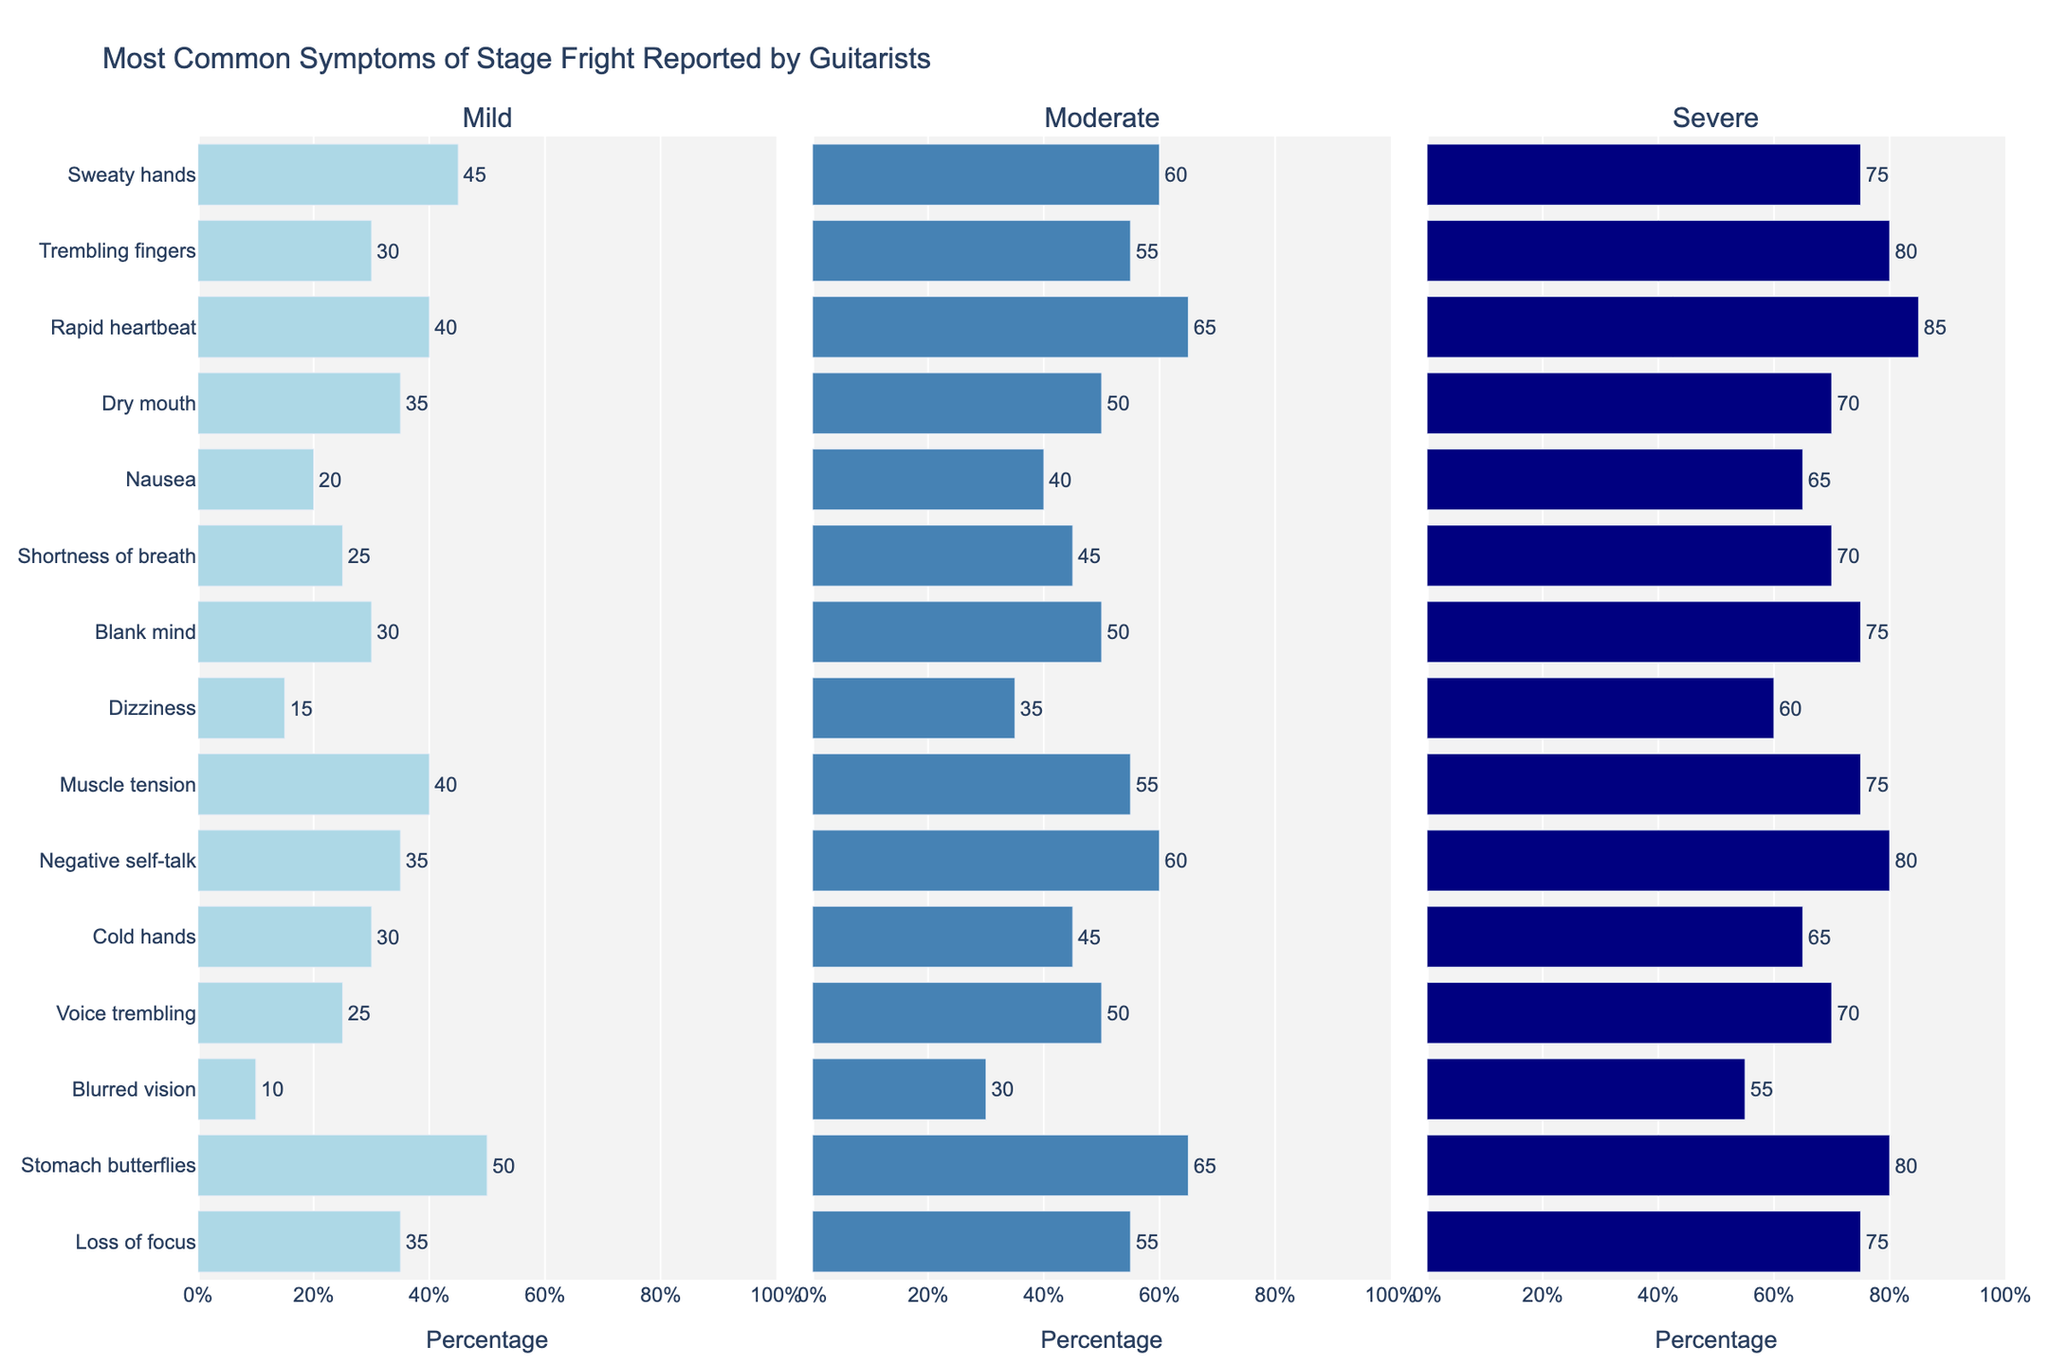Which symptom has the highest percentage reported for severe stage fright? Look at the "Severe" category and identify the bar with the longest length. Rapid Heartbeat has the highest percentage for sever stage fright.
Answer: Rapid Heartbeat Which symptom shows the largest difference in percentage between mild and severe categories? Calculate the difference between percentages for severe and mild categories for each symptom and identify the largest one. Rapid Heartbeat has a difference of 85 - 40 = 45 percentage points.
Answer: Rapid Heartbeat Between Mild and Moderate categories, which symptom has the biggest increase in percentage? Calculate the difference between the percentages in the "Moderate" and "Mild" columns for each symptom. Rapid Heartbeat shows the biggest increase with an increase of 65 - 40 = 25 percentage points.
Answer: Rapid Heartbeat What is the average percentage of guitarists reporting Dizziness for all severity levels? Sum the percentages of guitarists reporting Dizziness for mild (15), moderate (35), and severe (60) levels and then divide by 3. The average is (15 + 35 + 60) / 3 = 110 / 3 ≈ 36.67%.
Answer: 36.67% For which severity level is Stomach butterflies more commonly reported than Negative self-talk? Compare the percentages for Stomach butterflies and Negative self-talk in the Mild, Moderate, and Severe categories. Stomach butterflies are more commonly reported than Negative self-talk in the Mild category (50 vs. 35).
Answer: Mild Which symptom consistently appears in the top three most reported for all severity levels? By comparing all three severity categories, observe symptoms that have some of the highest percentages. Rapid Heartbeat and Stomach butterflies show high percentages across mild, moderate, and severe levels.
Answer: Rapid Heartbeat and Stomach Butterflies If you sum up the mild percentages for Sweaty hands, Trembling fingers, and Rapid heartbeat, what do you get? Add the mild percentages for Sweaty hands (45), Trembling fingers (30), and Rapid heartbeat (40) together: 45 + 30 + 40 = 115.
Answer: 115 Which two symptoms have the closest percentages in the severe category? Compare the values for symptoms in the severe category to identify the closest ones. Trembling Fingers and Blank Mind are closest with 80 and 75 respectively, having a difference of 5 percentage points.
Answer: Trembling Fingers and Blank Mind How much higher is the percentage of Dry mouth in the moderate category compared to the mild category? Subtract the mild percentage of Dry Mouth from the moderate percentage: 50 - 35 = 15 percentage points higher.
Answer: 15 Is the percentage of guitarists reporting Voice trembling higher in the moderate or severe category? Compare the values for Voice trembling in the moderate (50) and severe (70) categories. The percentage in the severe category is higher.
Answer: Severe 